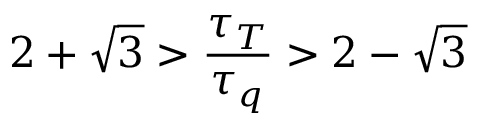Convert formula to latex. <formula><loc_0><loc_0><loc_500><loc_500>2 + \sqrt { 3 } > \frac { \tau _ { T } } { \tau _ { q } } > 2 - \sqrt { 3 }</formula> 